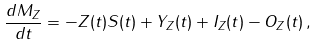<formula> <loc_0><loc_0><loc_500><loc_500>\frac { d M _ { Z } } { d t } = - Z ( t ) S ( t ) + Y _ { Z } ( t ) + I _ { Z } ( t ) - O _ { Z } ( t ) \, ,</formula> 